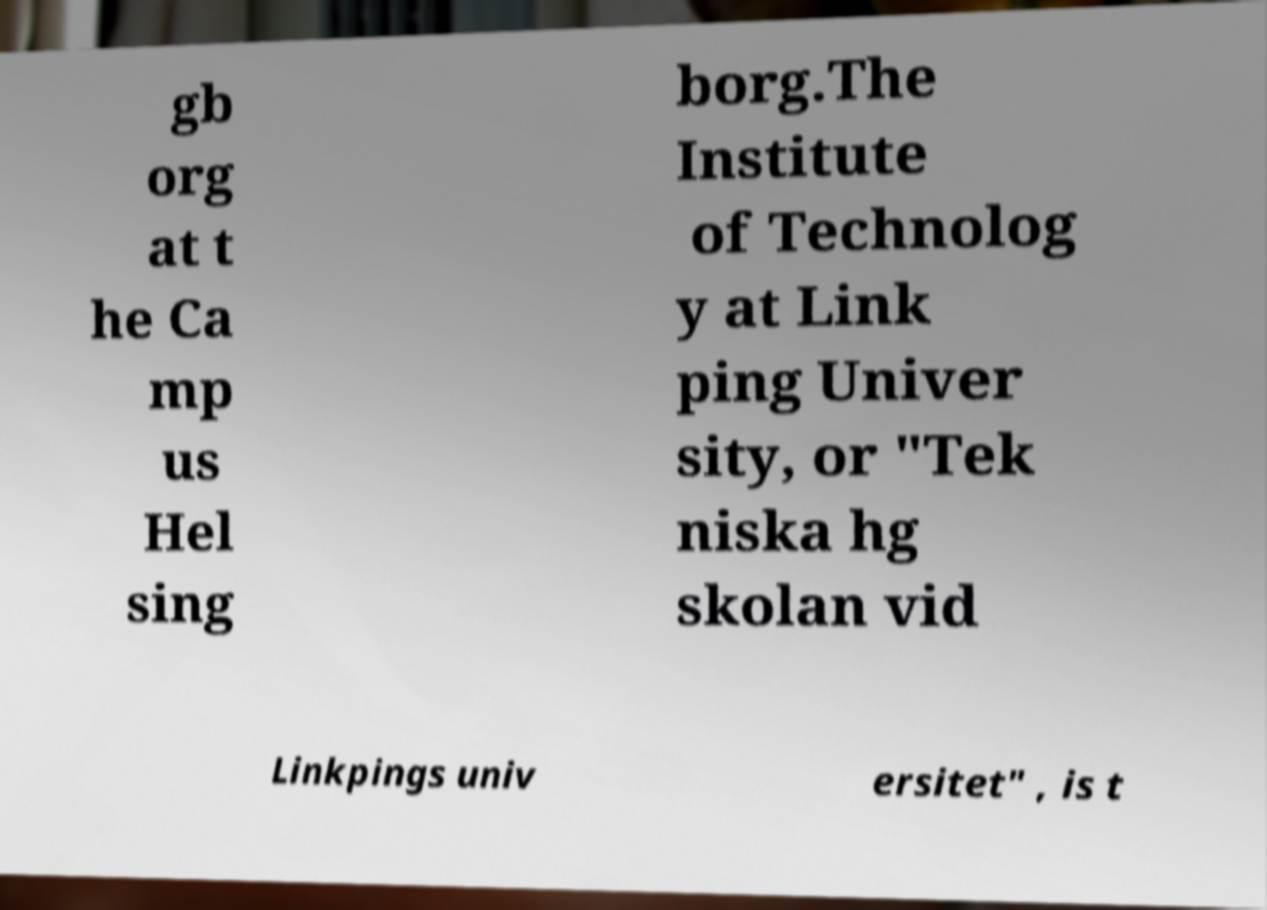Can you accurately transcribe the text from the provided image for me? gb org at t he Ca mp us Hel sing borg.The Institute of Technolog y at Link ping Univer sity, or "Tek niska hg skolan vid Linkpings univ ersitet" , is t 